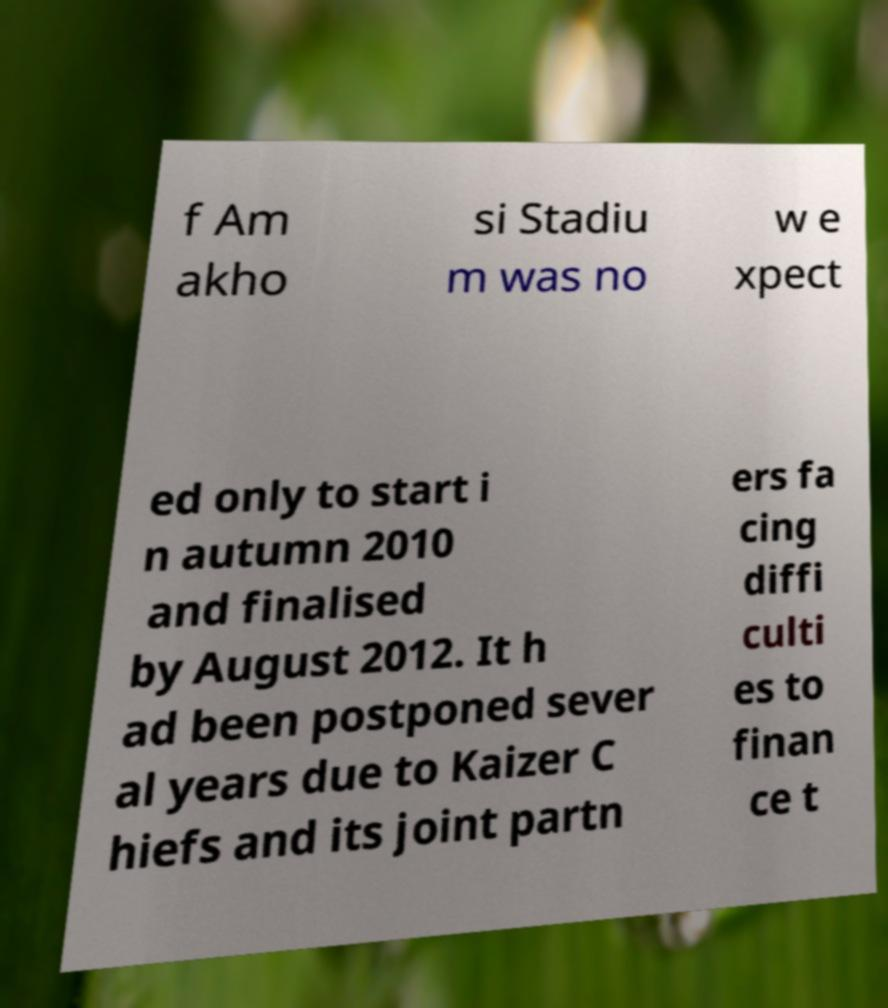Please identify and transcribe the text found in this image. f Am akho si Stadiu m was no w e xpect ed only to start i n autumn 2010 and finalised by August 2012. It h ad been postponed sever al years due to Kaizer C hiefs and its joint partn ers fa cing diffi culti es to finan ce t 